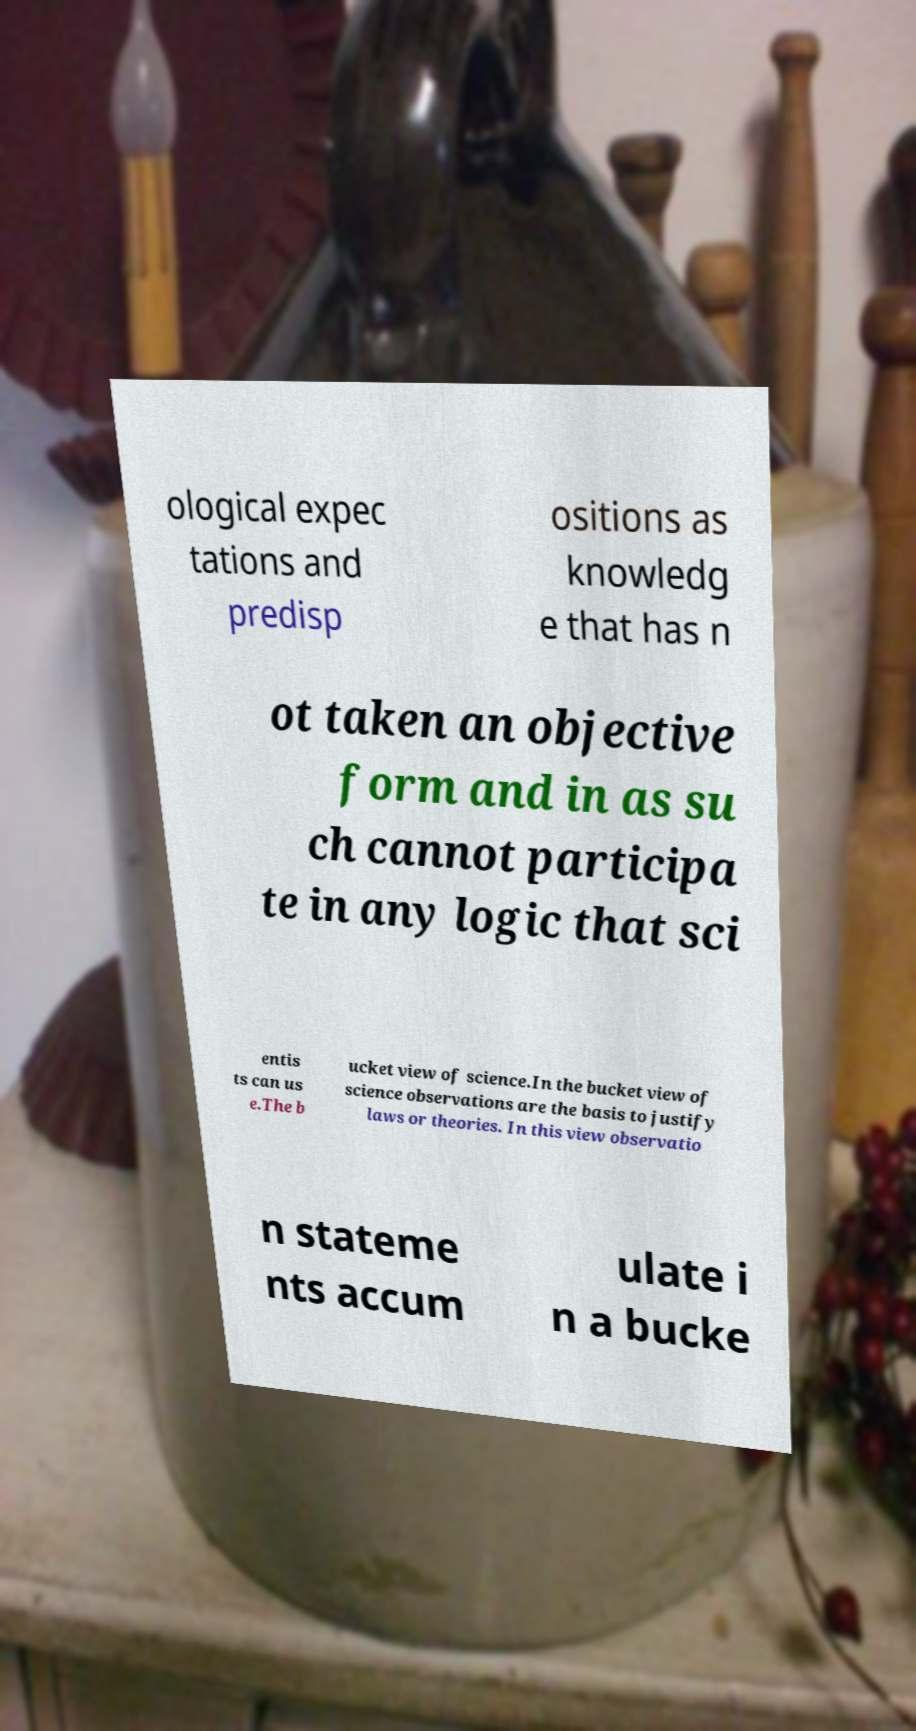Can you read and provide the text displayed in the image?This photo seems to have some interesting text. Can you extract and type it out for me? ological expec tations and predisp ositions as knowledg e that has n ot taken an objective form and in as su ch cannot participa te in any logic that sci entis ts can us e.The b ucket view of science.In the bucket view of science observations are the basis to justify laws or theories. In this view observatio n stateme nts accum ulate i n a bucke 